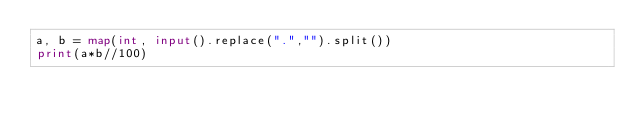Convert code to text. <code><loc_0><loc_0><loc_500><loc_500><_Python_>a, b = map(int, input().replace(".","").split())
print(a*b//100)
</code> 